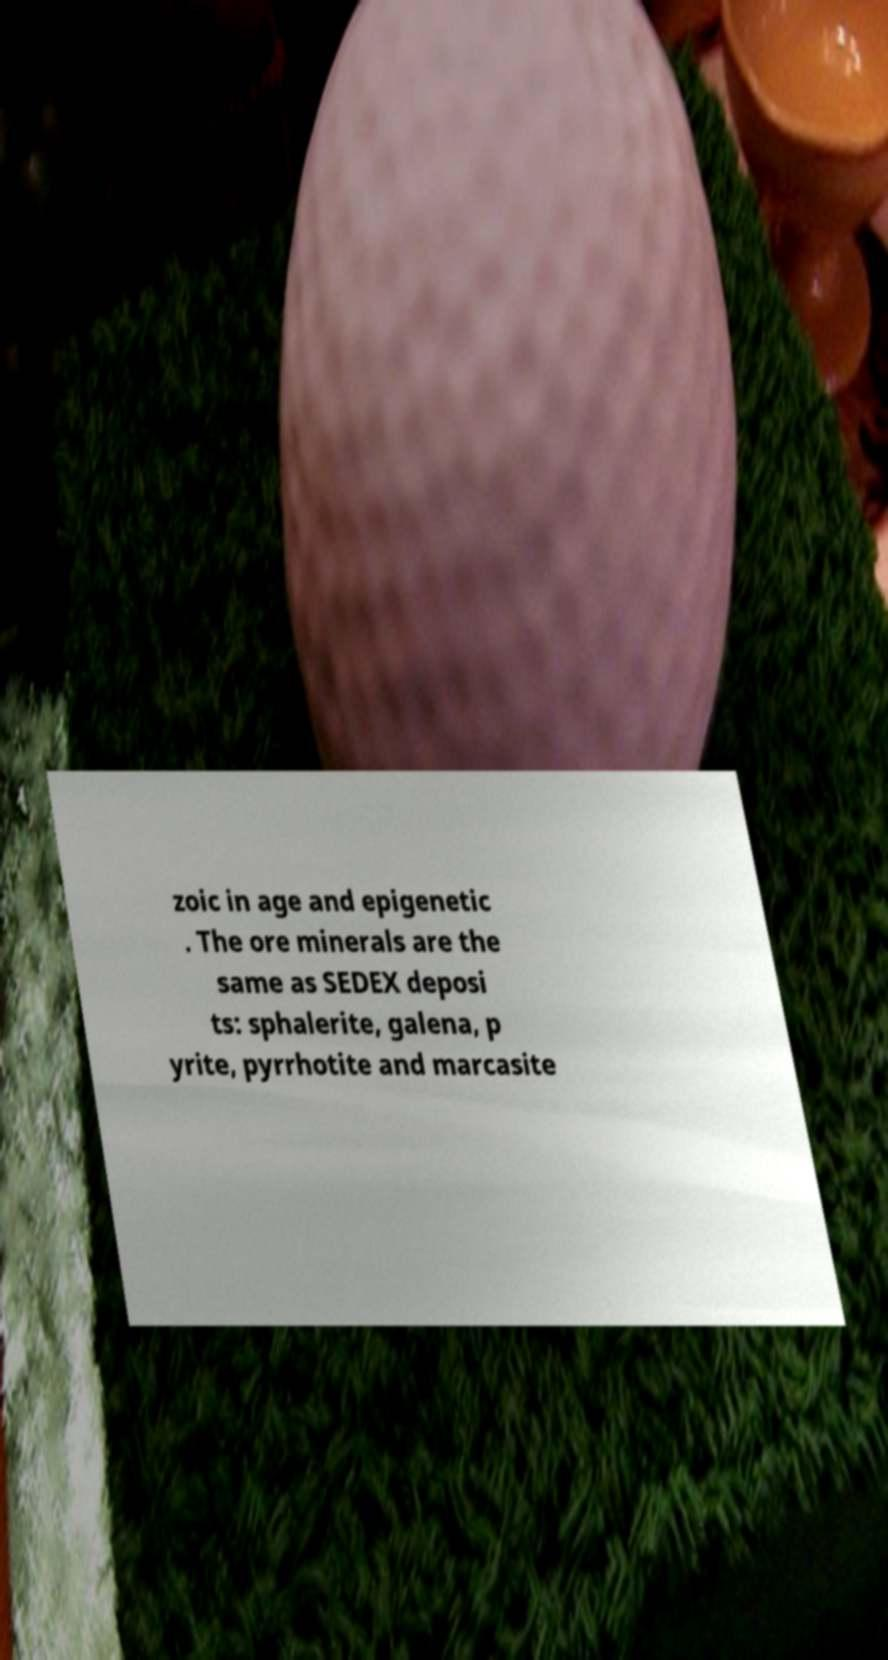Could you extract and type out the text from this image? zoic in age and epigenetic . The ore minerals are the same as SEDEX deposi ts: sphalerite, galena, p yrite, pyrrhotite and marcasite 